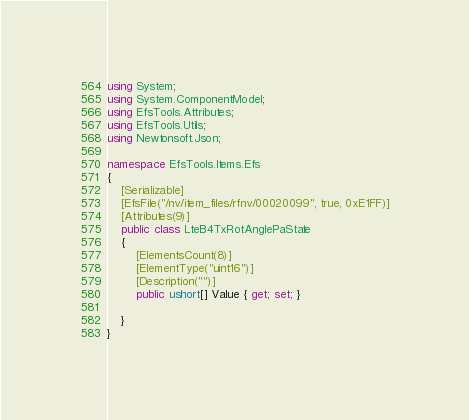<code> <loc_0><loc_0><loc_500><loc_500><_C#_>using System;
using System.ComponentModel;
using EfsTools.Attributes;
using EfsTools.Utils;
using Newtonsoft.Json;

namespace EfsTools.Items.Efs
{
    [Serializable]
    [EfsFile("/nv/item_files/rfnv/00020099", true, 0xE1FF)]
    [Attributes(9)]
    public class LteB4TxRotAnglePaState
    {
        [ElementsCount(8)]
        [ElementType("uint16")]
        [Description("")]
        public ushort[] Value { get; set; }
        
    }
}
</code> 